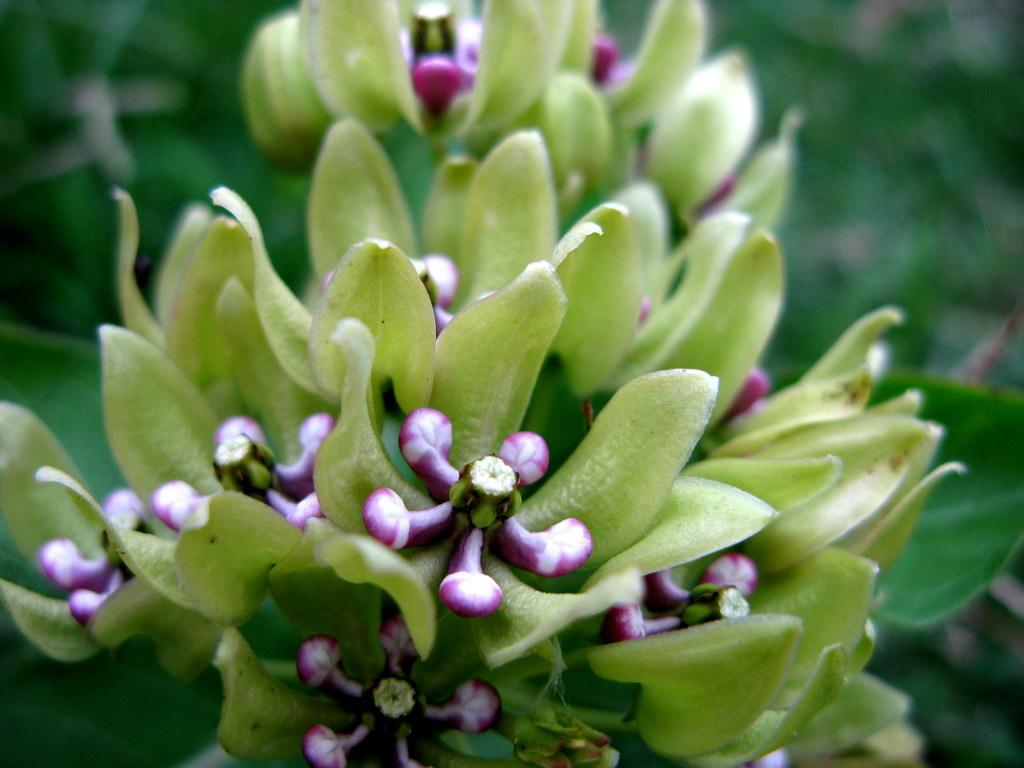What type of plants can be seen in the image? There are flowers in the image. What colors are the flowers? The flowers are in white and purple colors. What else can be seen in the image besides the flowers? There are leaves in the image. What color are the leaves? The leaves are in green color. How many quinces are hanging from the flowers in the image? There are no quinces present in the image; it features flowers and leaves. Can you describe the sound of the flowers sneezing in the image? Flowers do not have the ability to sneeze, so there is no sound of sneezing in the image. 